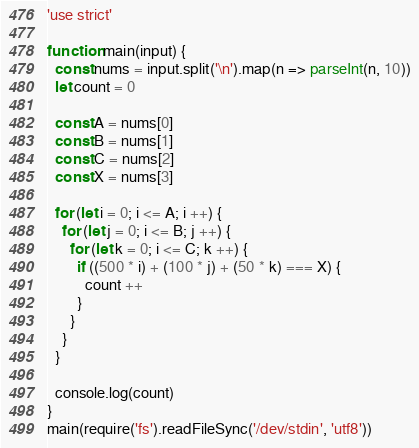Convert code to text. <code><loc_0><loc_0><loc_500><loc_500><_JavaScript_>'use strict'

function main(input) {
  const nums = input.split('\n').map(n => parseInt(n, 10))
  let count = 0

  const A = nums[0]
  const B = nums[1]
  const C = nums[2]
  const X = nums[3]

  for (let i = 0; i <= A; i ++) {
    for (let j = 0; i <= B; j ++) {
      for (let k = 0; i <= C; k ++) {
        if ((500 * i) + (100 * j) + (50 * k) === X) {
          count ++
        }
      }
    }
  }

  console.log(count)
}
main(require('fs').readFileSync('/dev/stdin', 'utf8'))
</code> 